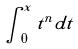Convert formula to latex. <formula><loc_0><loc_0><loc_500><loc_500>\int _ { 0 } ^ { x } t ^ { n } d t</formula> 